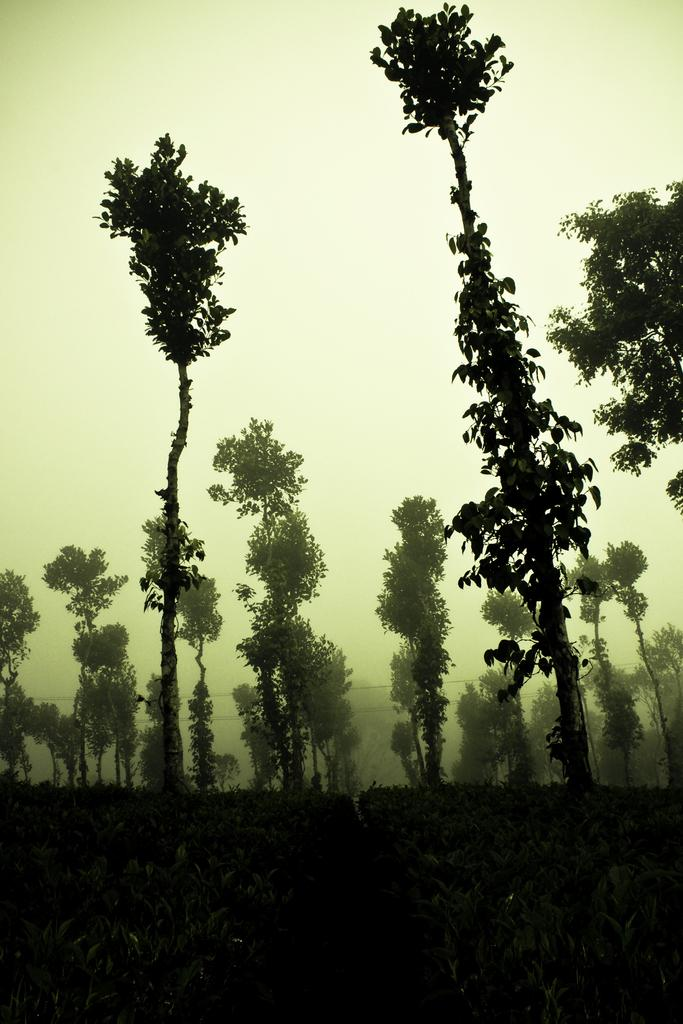What type of vegetation can be seen in the image? There are trees and plants in the image. What is the primary surface visible in the image? The land is visible in the image. What part of the natural environment is visible in the image? The sky is visible in the image. What type of bells can be heard ringing in the image? There are no bells present in the image, and therefore no sound can be heard. 